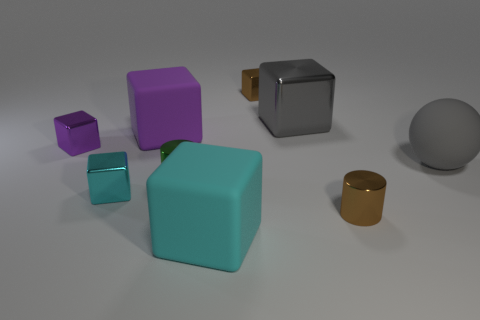What is the color of the large shiny thing that is the same shape as the small purple thing?
Provide a succinct answer. Gray. Does the small purple object have the same shape as the big gray metallic thing?
Ensure brevity in your answer.  Yes. There is a brown object that is the same shape as the large cyan matte object; what is its size?
Give a very brief answer. Small. Are there more purple blocks that are right of the big sphere than tiny green shiny cylinders that are right of the tiny cyan block?
Provide a short and direct response. No. What material is the other large thing that is the same color as the large shiny thing?
Keep it short and to the point. Rubber. What number of spheres are the same color as the big metal cube?
Your response must be concise. 1. There is a brown metallic object that is in front of the small cyan shiny thing; what is its shape?
Your answer should be compact. Cylinder. What is the size of the object that is the same color as the large metallic block?
Offer a very short reply. Large. Are there any gray cubes that have the same size as the gray metal object?
Give a very brief answer. No. Does the cylinder that is on the right side of the gray metallic cube have the same material as the green cylinder?
Keep it short and to the point. Yes. 